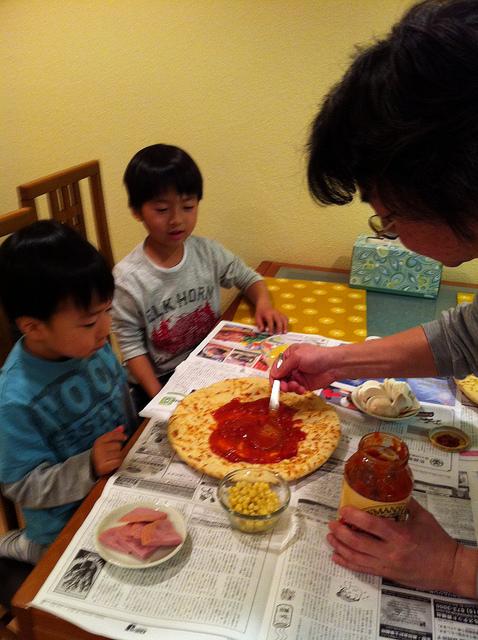Are the children sitting?
Give a very brief answer. Yes. What are they sitting on?
Give a very brief answer. Chairs. Are they at a restaurant?
Be succinct. No. What are they making?
Short answer required. Pizza. 